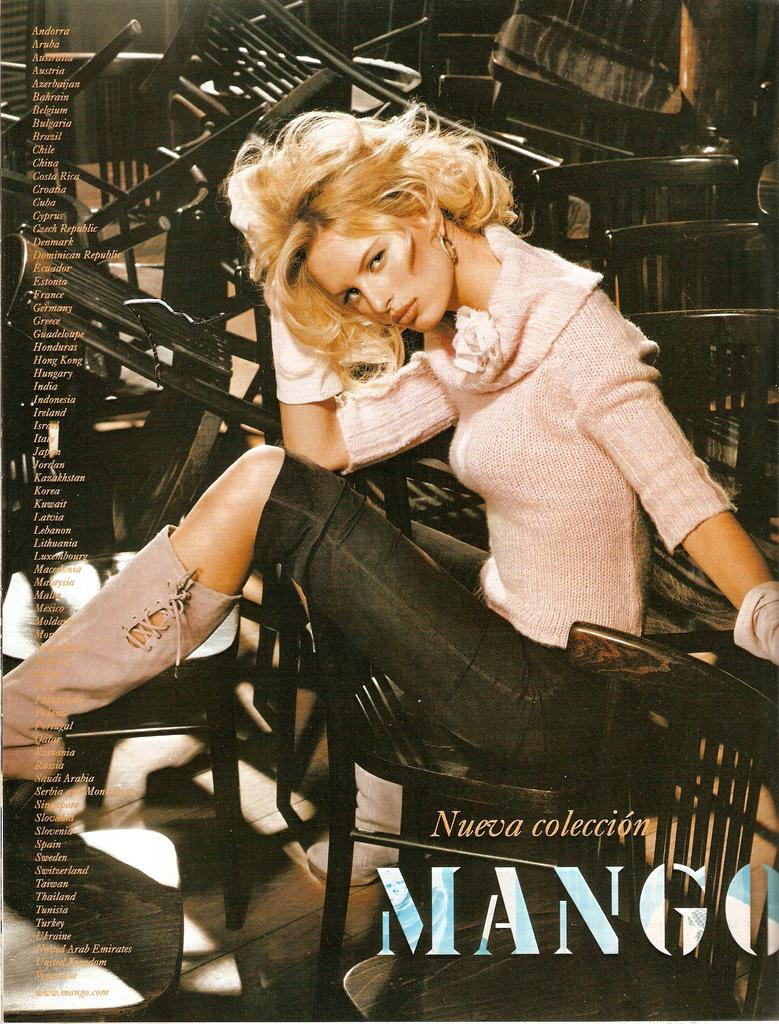What is the woman in the image doing? The woman is sitting on a chair in the image. How many chairs can be seen in the image? There are chairs visible in the image. What else is present in the image besides the woman and chairs? There is text present in the image. What type of art can be seen on the sidewalk in the image? There is no sidewalk or art present in the image; it only features a woman sitting on a chair and text. 